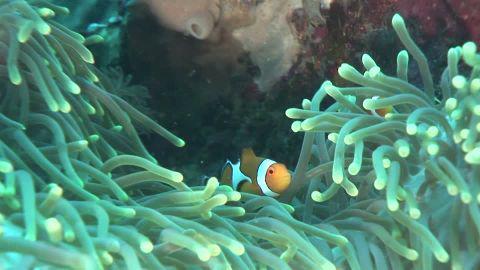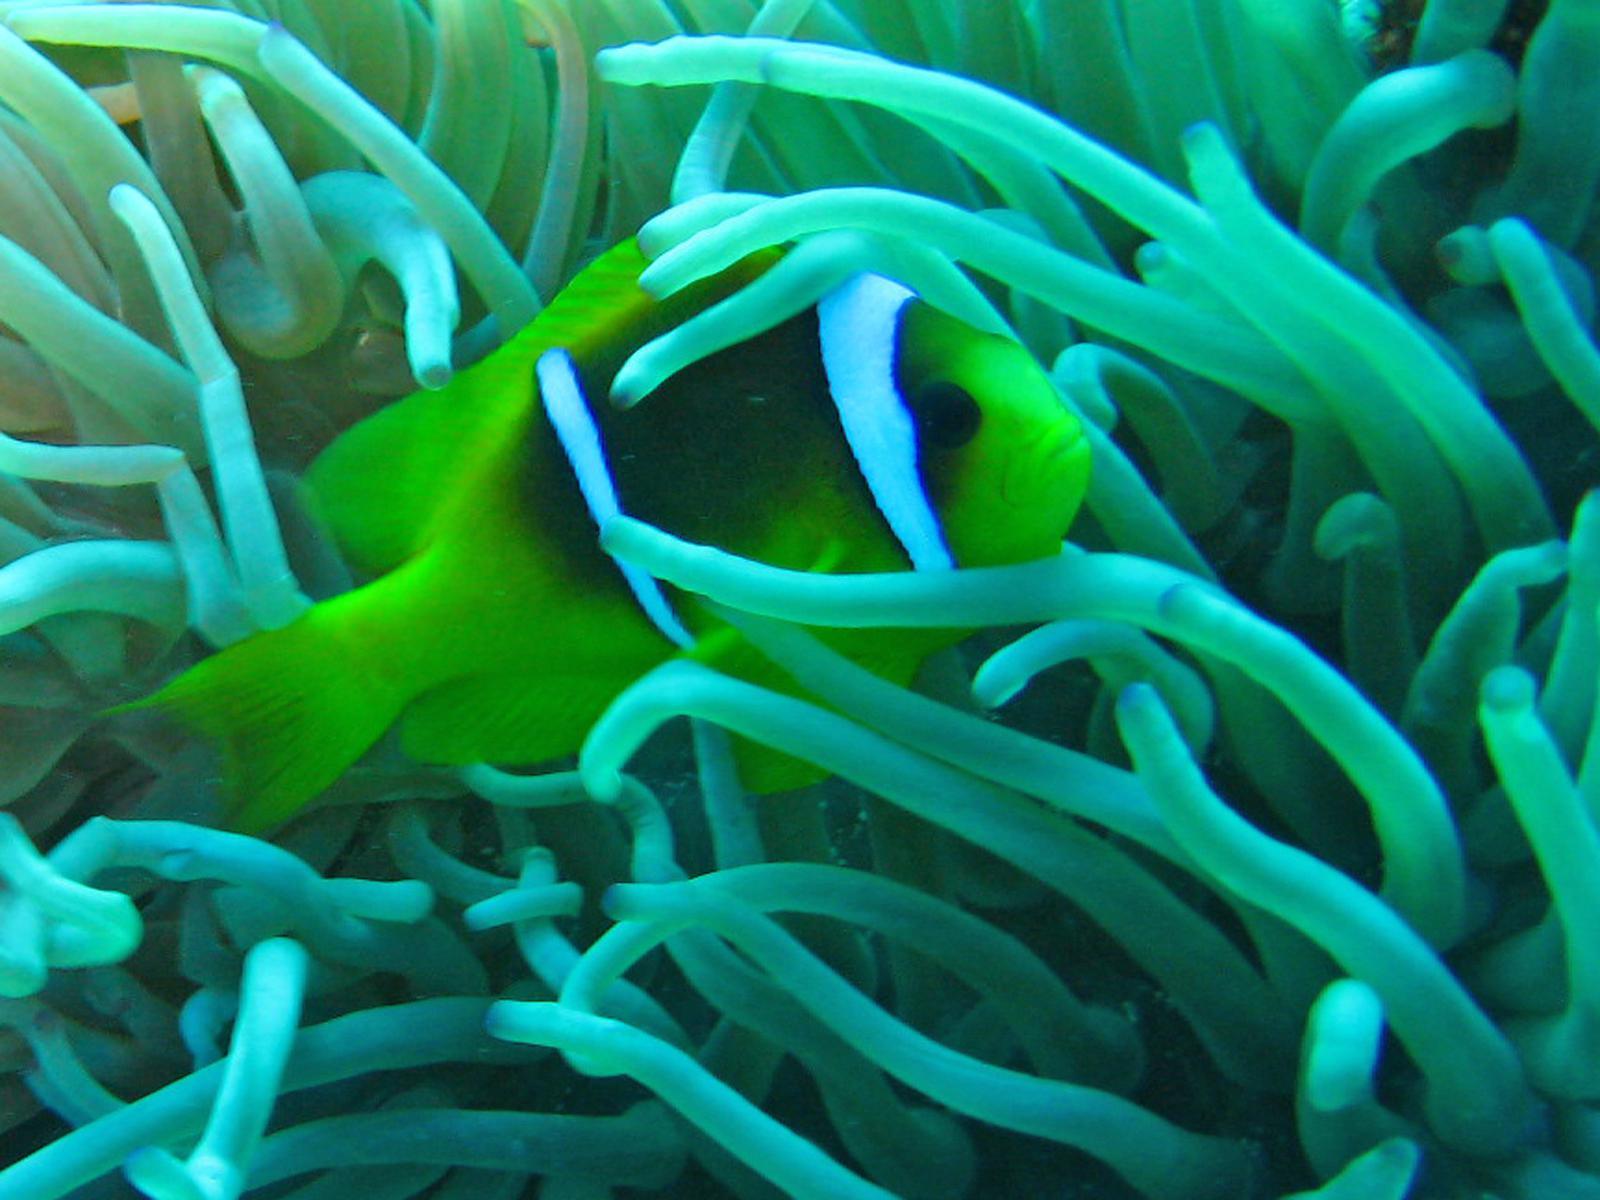The first image is the image on the left, the second image is the image on the right. Analyze the images presented: Is the assertion "Each image shows orange-and-white clown fish swimming among slender green anemone tendrils." valid? Answer yes or no. No. The first image is the image on the left, the second image is the image on the right. Analyze the images presented: Is the assertion "There is exactly one fish in the right image." valid? Answer yes or no. Yes. 